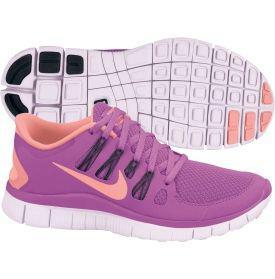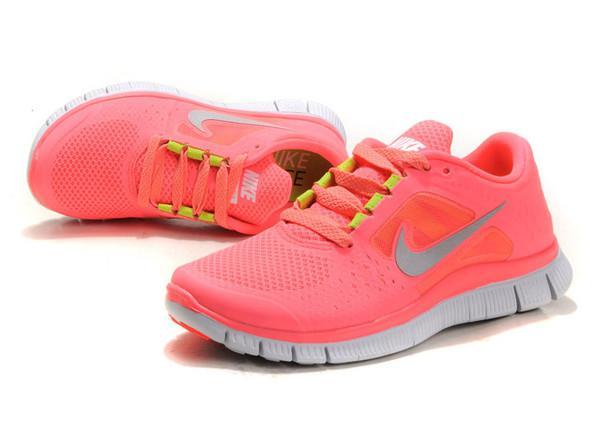The first image is the image on the left, the second image is the image on the right. For the images displayed, is the sentence "Each image shows one laced-up shoe with a logo in profile, while a second shoe is angled behind it with the sole displayed." factually correct? Answer yes or no. No. The first image is the image on the left, the second image is the image on the right. Given the left and right images, does the statement "The bottom of a shoe sole is displayed facing the camera in each image." hold true? Answer yes or no. No. 